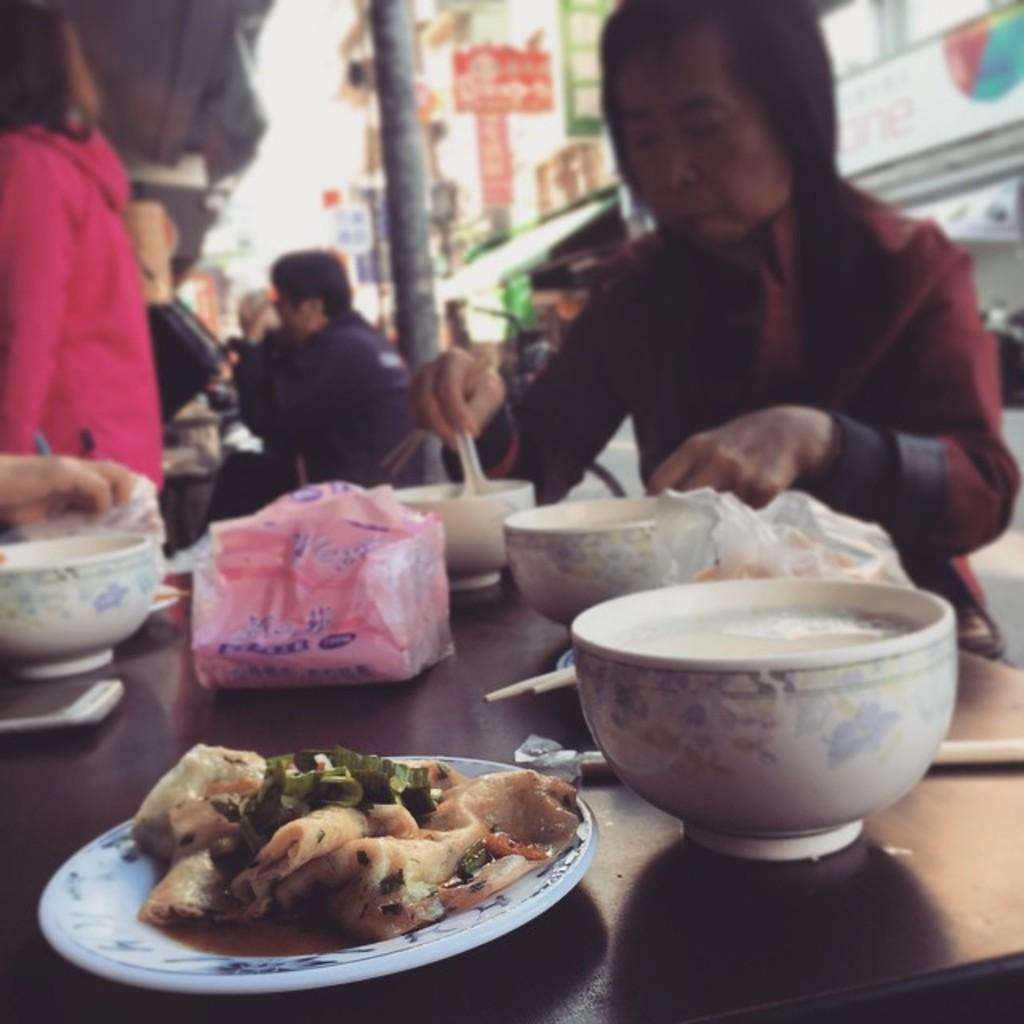What is being served on the plate in the image? The facts do not specify what is being served on the plate, so we cannot answer that question definitively. What type of containers are on the table in the image? There are bowls on the table in the image. Who is present in the image? There are people present in the image. What can be seen in the background of the image? Buildings are visible in the image. Can you tell me how many mice are hiding under the table in the image? There is no mention of mice in the image, so we cannot answer that question. What type of camera is being used to take the picture? The facts do not mention a camera, so we cannot answer that question. 